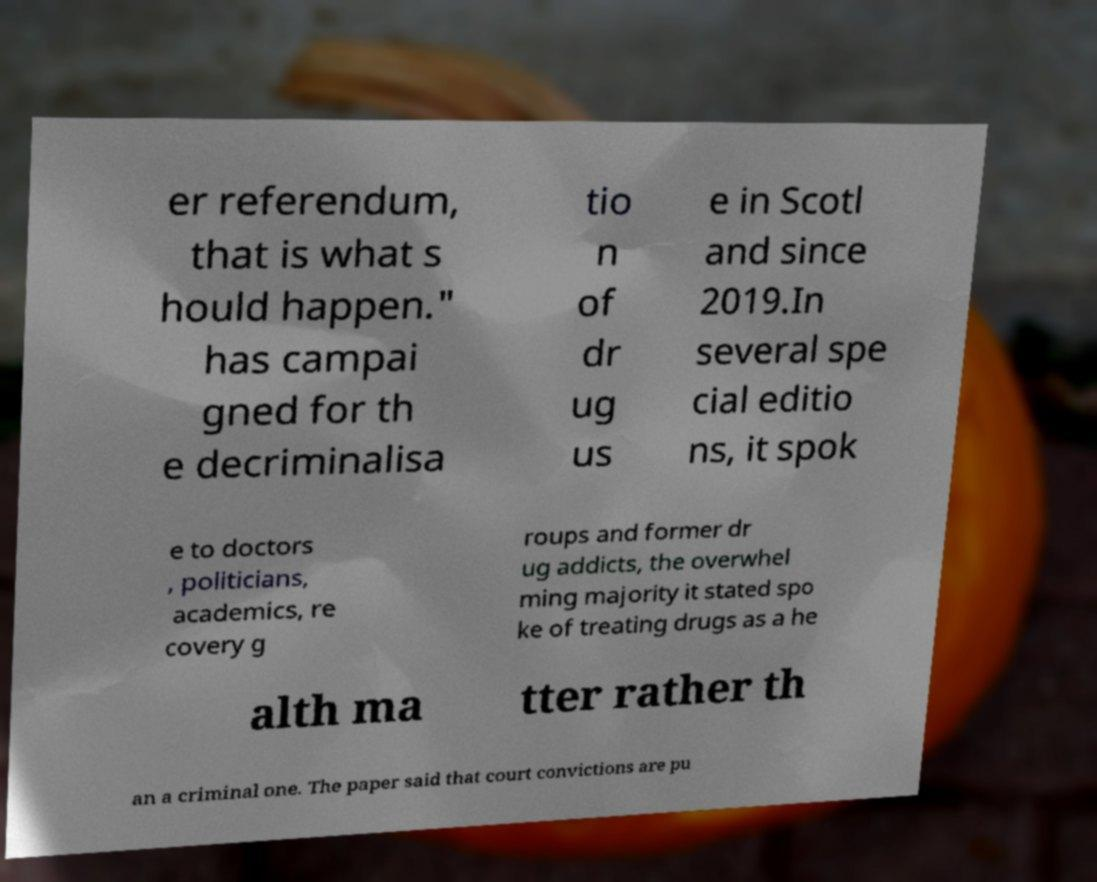Can you read and provide the text displayed in the image?This photo seems to have some interesting text. Can you extract and type it out for me? er referendum, that is what s hould happen." has campai gned for th e decriminalisa tio n of dr ug us e in Scotl and since 2019.In several spe cial editio ns, it spok e to doctors , politicians, academics, re covery g roups and former dr ug addicts, the overwhel ming majority it stated spo ke of treating drugs as a he alth ma tter rather th an a criminal one. The paper said that court convictions are pu 